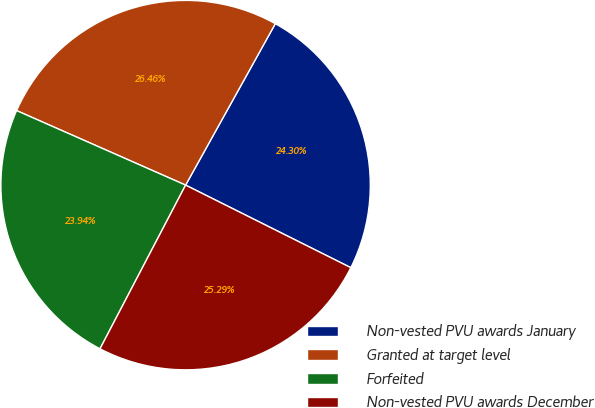<chart> <loc_0><loc_0><loc_500><loc_500><pie_chart><fcel>Non-vested PVU awards January<fcel>Granted at target level<fcel>Forfeited<fcel>Non-vested PVU awards December<nl><fcel>24.3%<fcel>26.46%<fcel>23.94%<fcel>25.29%<nl></chart> 